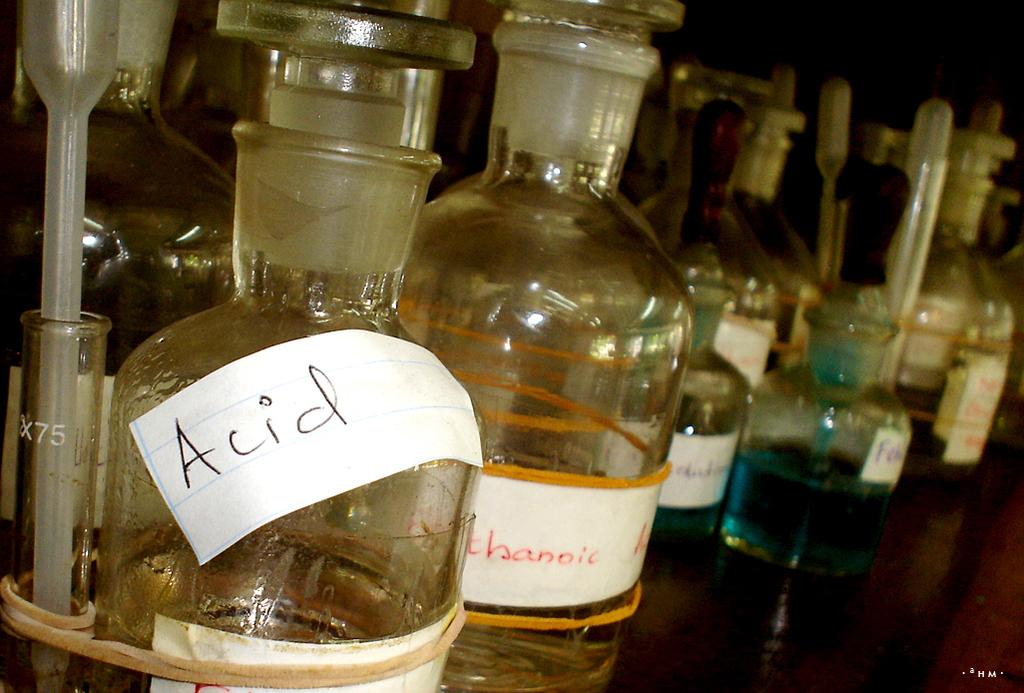Provide a one-sentence caption for the provided image. Someone has labeled a bottle of Acid with a paper label. 